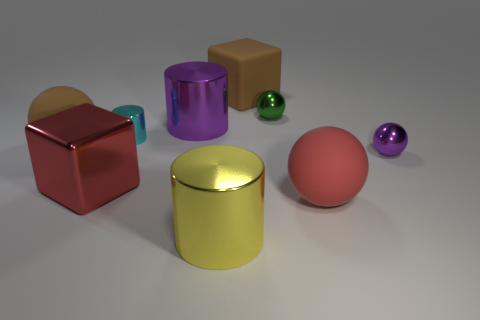Is the number of shiny balls that are to the left of the purple metallic ball greater than the number of brown rubber spheres in front of the red rubber object?
Provide a short and direct response. Yes. How big is the shiny thing that is on the right side of the green shiny thing that is behind the brown thing that is to the left of the purple metallic cylinder?
Your answer should be very brief. Small. Are there any tiny balls of the same color as the tiny cylinder?
Your answer should be compact. No. What number of tiny purple objects are there?
Make the answer very short. 1. There is a brown thing that is in front of the metallic ball behind the purple thing on the right side of the green metal sphere; what is it made of?
Offer a terse response. Rubber. Is there a gray ball made of the same material as the small cylinder?
Provide a short and direct response. No. Are the red ball and the large yellow cylinder made of the same material?
Provide a short and direct response. No. How many cylinders are either big brown rubber things or metal things?
Your answer should be compact. 3. What is the color of the other sphere that is made of the same material as the big red sphere?
Your answer should be compact. Brown. Are there fewer brown rubber things than large red balls?
Offer a terse response. No. 